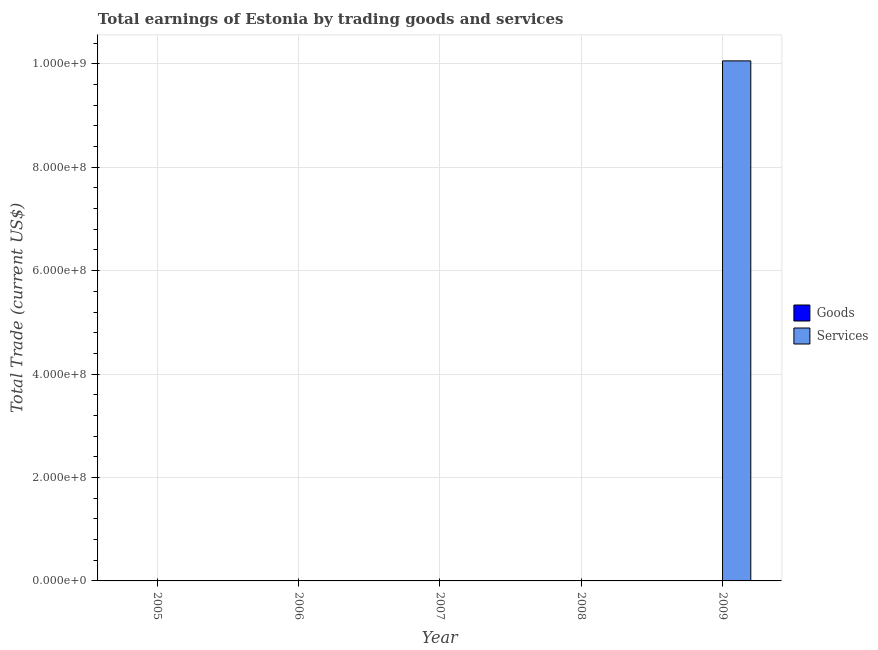Are the number of bars per tick equal to the number of legend labels?
Offer a terse response. No. Are the number of bars on each tick of the X-axis equal?
Your response must be concise. No. How many bars are there on the 4th tick from the left?
Your response must be concise. 0. What is the label of the 5th group of bars from the left?
Your response must be concise. 2009. In how many cases, is the number of bars for a given year not equal to the number of legend labels?
Offer a very short reply. 5. Across all years, what is the maximum amount earned by trading services?
Keep it short and to the point. 1.01e+09. Across all years, what is the minimum amount earned by trading services?
Keep it short and to the point. 0. In which year was the amount earned by trading services maximum?
Ensure brevity in your answer.  2009. What is the difference between the amount earned by trading goods in 2005 and the amount earned by trading services in 2008?
Ensure brevity in your answer.  0. What is the average amount earned by trading services per year?
Your response must be concise. 2.01e+08. In how many years, is the amount earned by trading services greater than 440000000 US$?
Your answer should be compact. 1. What is the difference between the highest and the lowest amount earned by trading services?
Your response must be concise. 1.01e+09. Are all the bars in the graph horizontal?
Keep it short and to the point. No. Does the graph contain grids?
Make the answer very short. Yes. How are the legend labels stacked?
Offer a very short reply. Vertical. What is the title of the graph?
Make the answer very short. Total earnings of Estonia by trading goods and services. What is the label or title of the X-axis?
Provide a short and direct response. Year. What is the label or title of the Y-axis?
Your answer should be compact. Total Trade (current US$). What is the Total Trade (current US$) of Goods in 2006?
Offer a terse response. 0. What is the Total Trade (current US$) of Services in 2006?
Offer a terse response. 0. What is the Total Trade (current US$) in Goods in 2007?
Your answer should be very brief. 0. What is the Total Trade (current US$) in Services in 2007?
Ensure brevity in your answer.  0. What is the Total Trade (current US$) of Services in 2008?
Offer a very short reply. 0. What is the Total Trade (current US$) of Services in 2009?
Offer a terse response. 1.01e+09. Across all years, what is the maximum Total Trade (current US$) of Services?
Keep it short and to the point. 1.01e+09. Across all years, what is the minimum Total Trade (current US$) in Services?
Ensure brevity in your answer.  0. What is the total Total Trade (current US$) of Services in the graph?
Ensure brevity in your answer.  1.01e+09. What is the average Total Trade (current US$) in Services per year?
Make the answer very short. 2.01e+08. What is the difference between the highest and the lowest Total Trade (current US$) of Services?
Keep it short and to the point. 1.01e+09. 